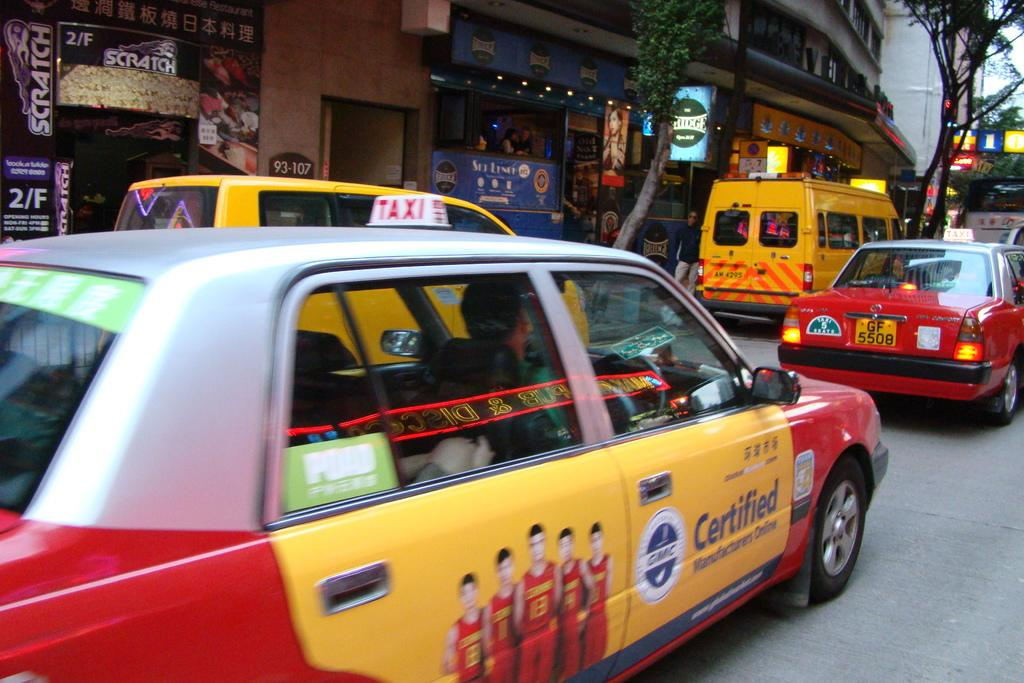<image>
Create a compact narrative representing the image presented. A taxi on a city street has Certified written on the passenger door. 